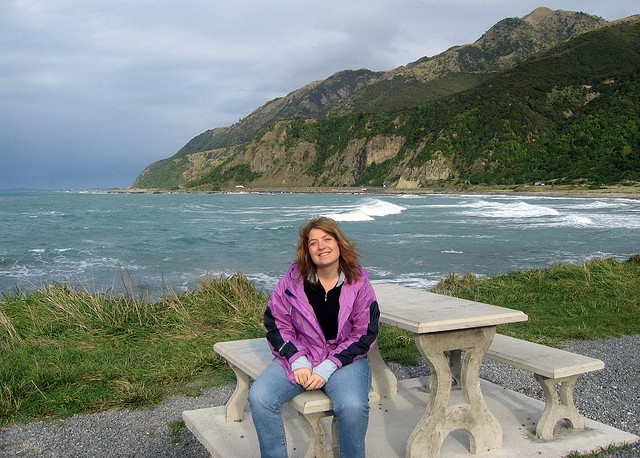Describe the objects in this image and their specific colors. I can see people in lightblue, black, magenta, and gray tones, dining table in lightblue, darkgray, lightgray, and gray tones, bench in lightblue, darkgray, gray, and lightgray tones, and bench in lightblue, darkgray, lightgray, tan, and gray tones in this image. 